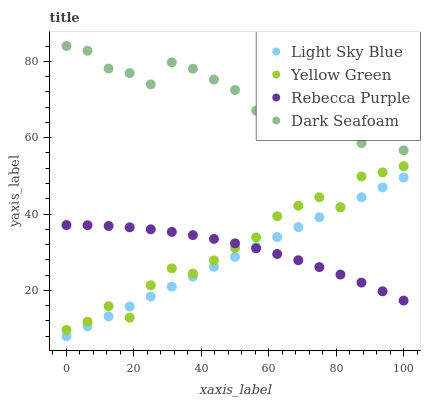Does Light Sky Blue have the minimum area under the curve?
Answer yes or no. Yes. Does Dark Seafoam have the maximum area under the curve?
Answer yes or no. Yes. Does Yellow Green have the minimum area under the curve?
Answer yes or no. No. Does Yellow Green have the maximum area under the curve?
Answer yes or no. No. Is Light Sky Blue the smoothest?
Answer yes or no. Yes. Is Dark Seafoam the roughest?
Answer yes or no. Yes. Is Yellow Green the smoothest?
Answer yes or no. No. Is Yellow Green the roughest?
Answer yes or no. No. Does Light Sky Blue have the lowest value?
Answer yes or no. Yes. Does Yellow Green have the lowest value?
Answer yes or no. No. Does Dark Seafoam have the highest value?
Answer yes or no. Yes. Does Light Sky Blue have the highest value?
Answer yes or no. No. Is Yellow Green less than Dark Seafoam?
Answer yes or no. Yes. Is Dark Seafoam greater than Light Sky Blue?
Answer yes or no. Yes. Does Light Sky Blue intersect Yellow Green?
Answer yes or no. Yes. Is Light Sky Blue less than Yellow Green?
Answer yes or no. No. Is Light Sky Blue greater than Yellow Green?
Answer yes or no. No. Does Yellow Green intersect Dark Seafoam?
Answer yes or no. No. 